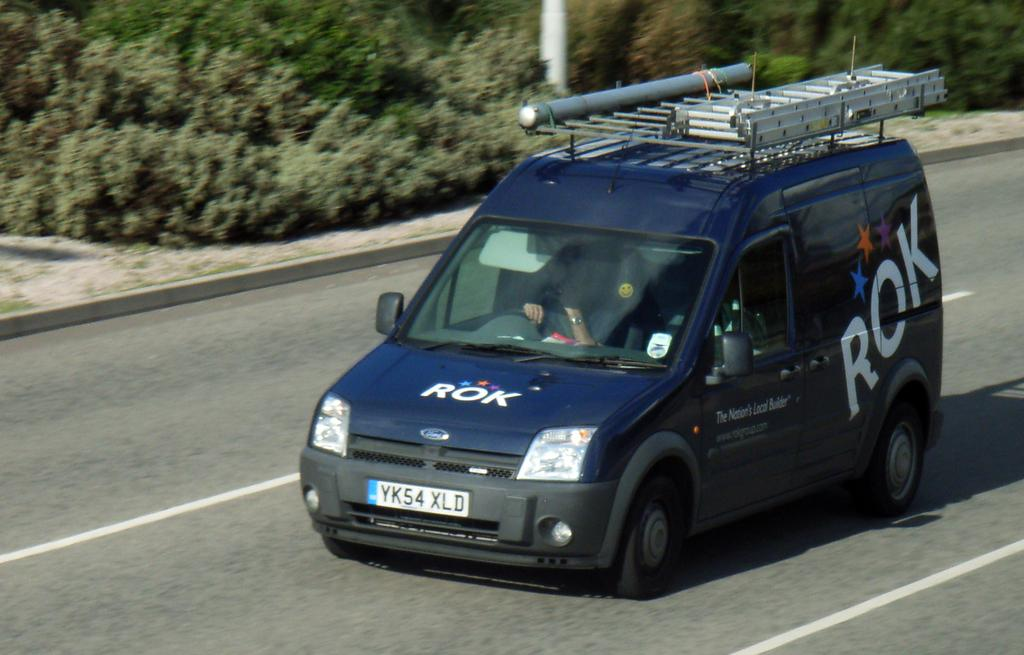What is the main subject of the image? The main subject of the image is a car. Where is the car located in the image? The car is parked on the road in the image. What can be seen behind the car in the image? There are plants on the ground behind the car. What type of locket is hanging from the rearview mirror of the car in the image? There is no locket visible in the image; the focus is on the car, its location, and the plants behind it. 